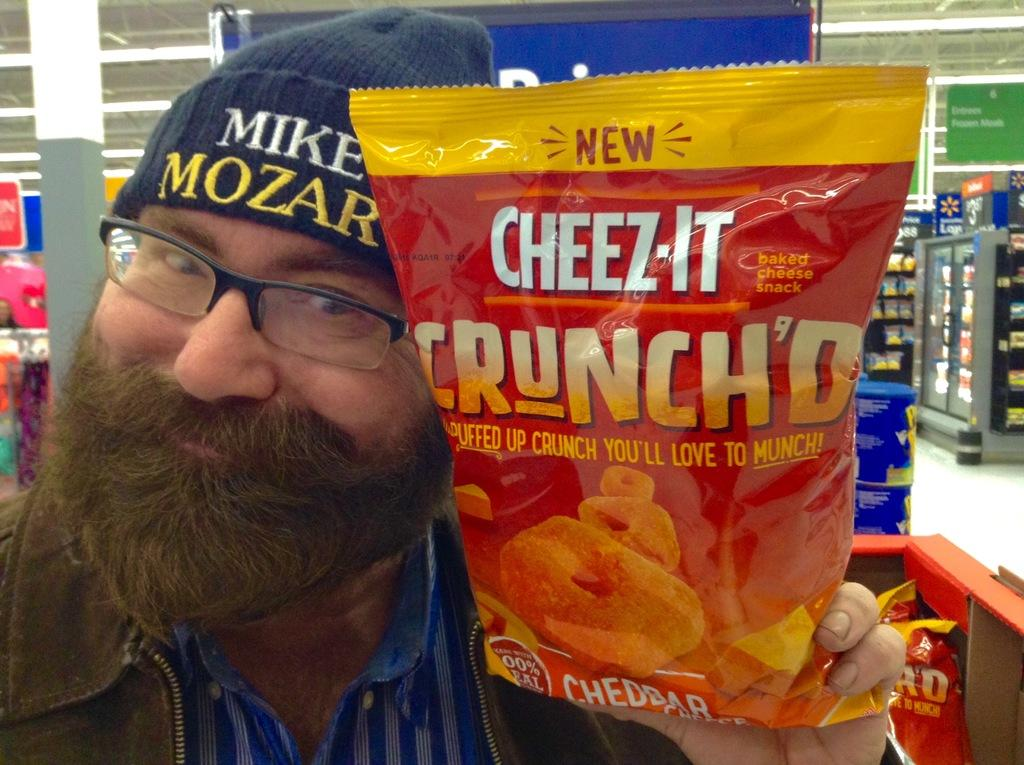Who is the person in the image? There is a man in the image. What is the man wearing? The man is wearing spectacles. What is the man holding in the image? The man is holding a food packet. What can be seen behind the man in the image? There are boards and other objects visible behind the man. What type of holiday is the man enjoying in the image? There is no indication of a holiday in the image; it simply shows a man holding a food packet. How comfortable is the chair the man is sitting on in the image? There is no chair visible in the image, so it is not possible to determine the comfort level of any seating. 